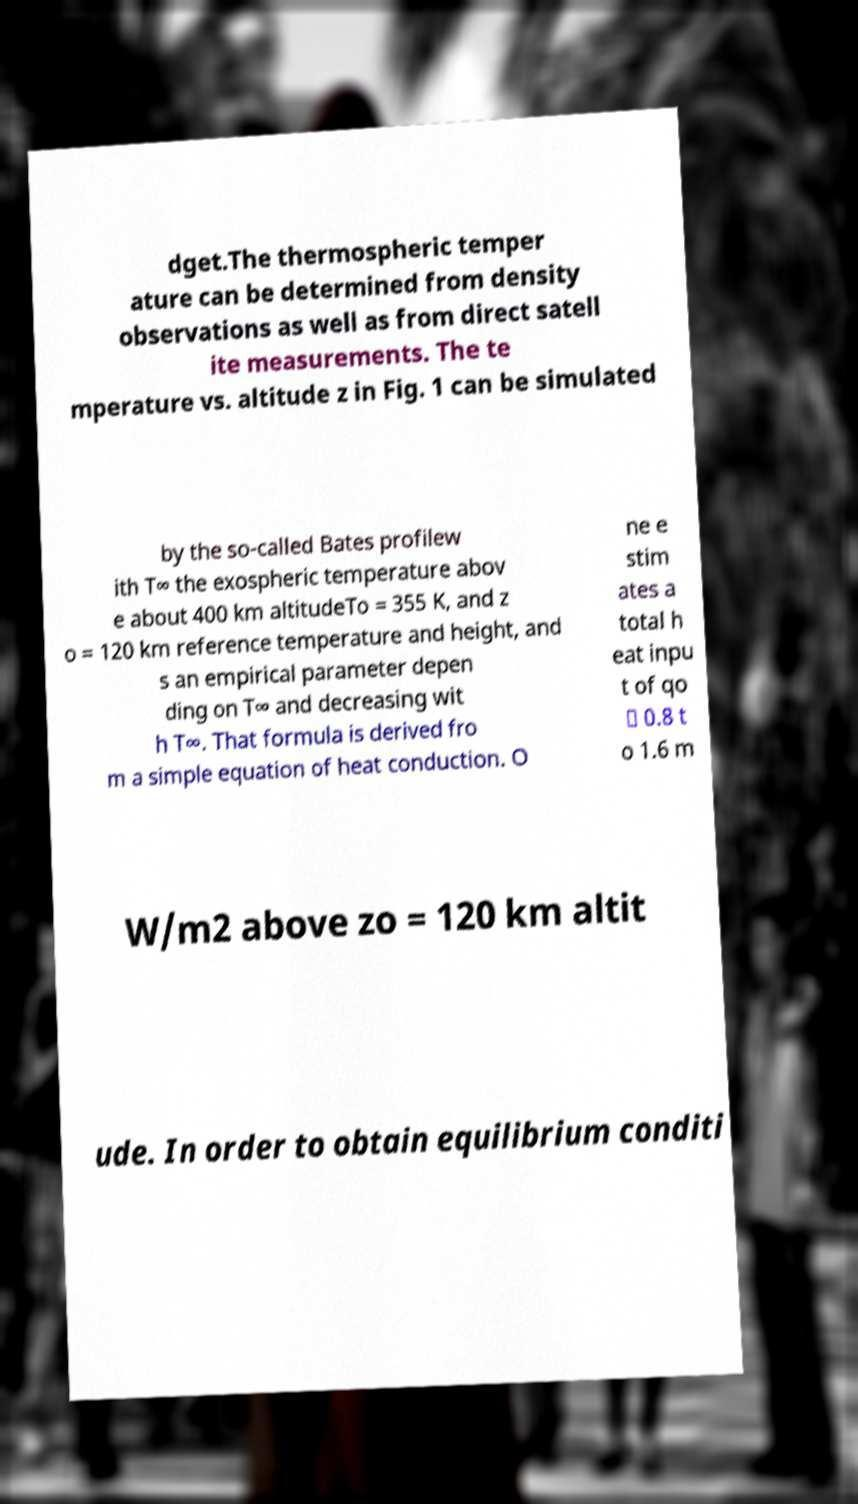I need the written content from this picture converted into text. Can you do that? dget.The thermospheric temper ature can be determined from density observations as well as from direct satell ite measurements. The te mperature vs. altitude z in Fig. 1 can be simulated by the so-called Bates profilew ith T∞ the exospheric temperature abov e about 400 km altitudeTo = 355 K, and z o = 120 km reference temperature and height, and s an empirical parameter depen ding on T∞ and decreasing wit h T∞. That formula is derived fro m a simple equation of heat conduction. O ne e stim ates a total h eat inpu t of qo ≃ 0.8 t o 1.6 m W/m2 above zo = 120 km altit ude. In order to obtain equilibrium conditi 